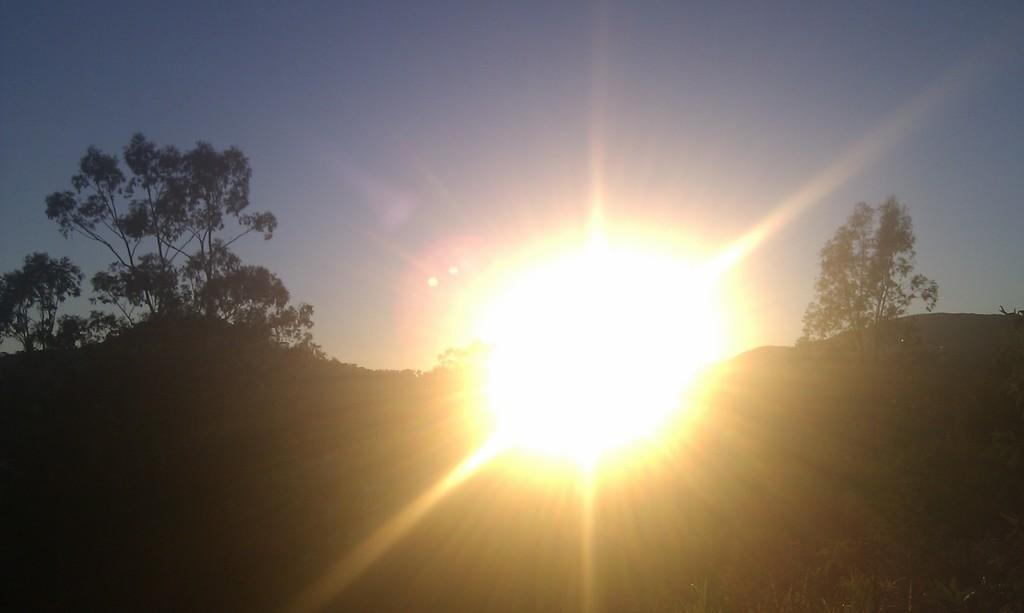What celestial body can be seen in the sky in the image? The sun is visible in the sky in the image. What type of vegetation is present on both sides of the image? There are trees on both sides of the image. What is located at the bottom of the image? There is a path or road at the bottom of the image. Can you see a chess game being played on the path in the image? There is no chess game or any indication of a game being played in the image. 